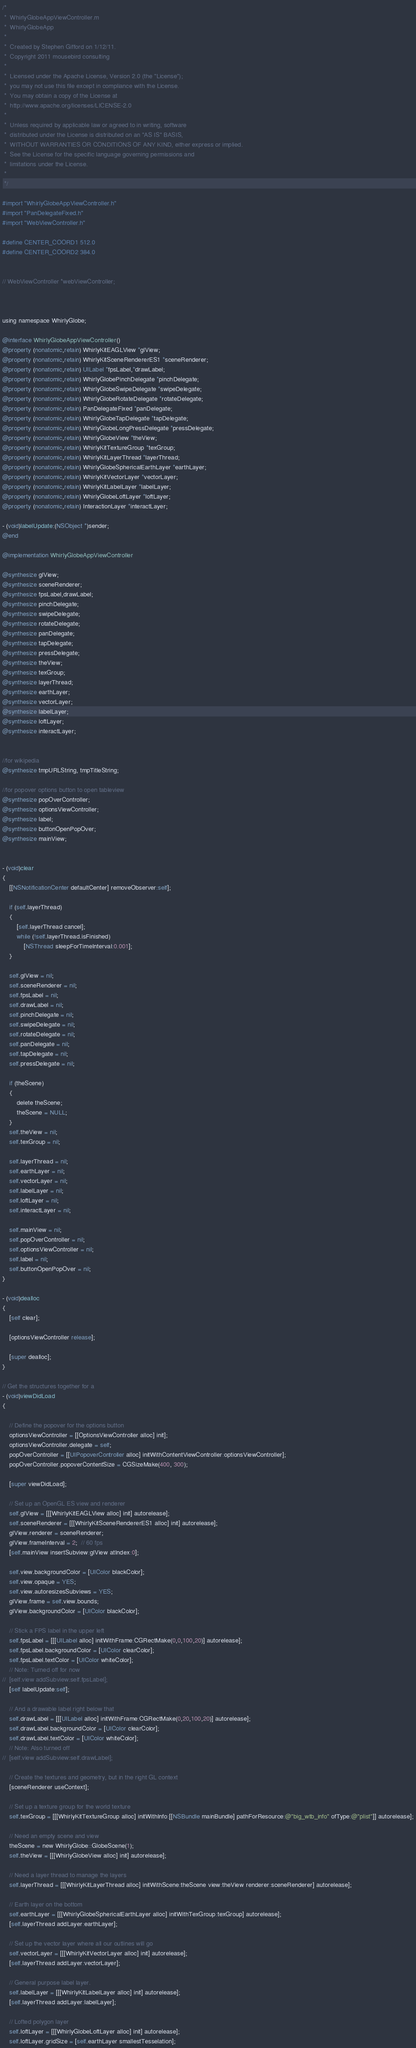Convert code to text. <code><loc_0><loc_0><loc_500><loc_500><_ObjectiveC_>/*
 *  WhirlyGlobeAppViewController.m
 *  WhirlyGlobeApp
 *
 *  Created by Stephen Gifford on 1/12/11.
 *  Copyright 2011 mousebird consulting
 *
 *  Licensed under the Apache License, Version 2.0 (the "License");
 *  you may not use this file except in compliance with the License.
 *  You may obtain a copy of the License at
 *  http://www.apache.org/licenses/LICENSE-2.0
 *
 *  Unless required by applicable law or agreed to in writing, software
 *  distributed under the License is distributed on an "AS IS" BASIS,
 *  WITHOUT WARRANTIES OR CONDITIONS OF ANY KIND, either express or implied.
 *  See the License for the specific language governing permissions and
 *  limitations under the License.
 *
 */

#import "WhirlyGlobeAppViewController.h"
#import "PanDelegateFixed.h"
#import "WebViewController.h"

#define CENTER_COORD1 512.0
#define CENTER_COORD2 384.0


// WebViewController *webViewController;



using namespace WhirlyGlobe;

@interface WhirlyGlobeAppViewController()
@property (nonatomic,retain) WhirlyKitEAGLView *glView;
@property (nonatomic,retain) WhirlyKitSceneRendererES1 *sceneRenderer;
@property (nonatomic,retain) UILabel *fpsLabel,*drawLabel;
@property (nonatomic,retain) WhirlyGlobePinchDelegate *pinchDelegate;
@property (nonatomic,retain) WhirlyGlobeSwipeDelegate *swipeDelegate;
@property (nonatomic,retain) WhirlyGlobeRotateDelegate *rotateDelegate;
@property (nonatomic,retain) PanDelegateFixed *panDelegate;
@property (nonatomic,retain) WhirlyGlobeTapDelegate *tapDelegate;
@property (nonatomic,retain) WhirlyGlobeLongPressDelegate *pressDelegate;
@property (nonatomic,retain) WhirlyGlobeView *theView;
@property (nonatomic,retain) WhirlyKitTextureGroup *texGroup;
@property (nonatomic,retain) WhirlyKitLayerThread *layerThread;
@property (nonatomic,retain) WhirlyGlobeSphericalEarthLayer *earthLayer;
@property (nonatomic,retain) WhirlyKitVectorLayer *vectorLayer;
@property (nonatomic,retain) WhirlyKitLabelLayer *labelLayer;
@property (nonatomic,retain) WhirlyGlobeLoftLayer *loftLayer;
@property (nonatomic,retain) InteractionLayer *interactLayer;

- (void)labelUpdate:(NSObject *)sender;
@end

@implementation WhirlyGlobeAppViewController

@synthesize glView;
@synthesize sceneRenderer;
@synthesize fpsLabel,drawLabel;
@synthesize pinchDelegate;
@synthesize swipeDelegate;
@synthesize rotateDelegate;
@synthesize panDelegate;
@synthesize tapDelegate;
@synthesize pressDelegate;
@synthesize theView;
@synthesize texGroup;
@synthesize layerThread;
@synthesize earthLayer;
@synthesize vectorLayer;
@synthesize labelLayer;
@synthesize loftLayer;
@synthesize interactLayer;


//for wikipedia
@synthesize tmpURLString, tmpTitleString;

//for popover options button to open tableview
@synthesize popOverController;
@synthesize optionsViewController;
@synthesize label;
@synthesize buttonOpenPopOver;
@synthesize mainView;


- (void)clear
{
	[[NSNotificationCenter defaultCenter] removeObserver:self];

    if (self.layerThread)
    {
        [self.layerThread cancel];
        while (!self.layerThread.isFinished)
            [NSThread sleepForTimeInterval:0.001];
    }

    self.glView = nil;
    self.sceneRenderer = nil;
    self.fpsLabel = nil;
    self.drawLabel = nil;
    self.pinchDelegate = nil;
    self.swipeDelegate = nil;
    self.rotateDelegate = nil;
    self.panDelegate = nil;
    self.tapDelegate = nil;
    self.pressDelegate = nil;
    
    if (theScene)
    {
        delete theScene;
        theScene = NULL;
    }
    self.theView = nil;
    self.texGroup = nil;
    
    self.layerThread = nil;
    self.earthLayer = nil;
    self.vectorLayer = nil;
    self.labelLayer = nil;
    self.loftLayer = nil;
    self.interactLayer = nil;
    
    self.mainView = nil;
    self.popOverController = nil;
    self.optionsViewController = nil;
    self.label = nil;
    self.buttonOpenPopOver = nil;
}

- (void)dealloc 
{
    [self clear];
    
    [optionsViewController release];
    
    [super dealloc];
}

// Get the structures together for a 
- (void)viewDidLoad 
{
    
    // Define the popover for the options button
    optionsViewController = [[OptionsViewController alloc] init];
    optionsViewController.delegate = self;
    popOverController = [[UIPopoverController alloc] initWithContentViewController:optionsViewController];
    popOverController.popoverContentSize = CGSizeMake(400, 300);
    
    [super viewDidLoad];
	
	// Set up an OpenGL ES view and renderer
	self.glView = [[[WhirlyKitEAGLView alloc] init] autorelease];
	self.sceneRenderer = [[[WhirlyKitSceneRendererES1 alloc] init] autorelease];
	glView.renderer = sceneRenderer;
	glView.frameInterval = 2;  // 60 fps
    [self.mainView insertSubview:glView atIndex:0];

    self.view.backgroundColor = [UIColor blackColor];
    self.view.opaque = YES;
	self.view.autoresizesSubviews = YES;
	glView.frame = self.view.bounds;
    glView.backgroundColor = [UIColor blackColor];
	
	// Stick a FPS label in the upper left
	self.fpsLabel = [[[UILabel alloc] initWithFrame:CGRectMake(0,0,100,20)] autorelease];
	self.fpsLabel.backgroundColor = [UIColor clearColor];
	self.fpsLabel.textColor = [UIColor whiteColor];
    // Note: Turned off for now
//	[self.view addSubview:self.fpsLabel];
	[self labelUpdate:self];
	
	// And a drawable label right below that
	self.drawLabel = [[[UILabel alloc] initWithFrame:CGRectMake(0,20,100,20)] autorelease];
	self.drawLabel.backgroundColor = [UIColor clearColor];
	self.drawLabel.textColor = [UIColor whiteColor];
    // Note: Also turned off
//	[self.view addSubview:self.drawLabel];

	// Create the textures and geometry, but in the right GL context
	[sceneRenderer useContext];
	
	// Set up a texture group for the world texture
	self.texGroup = [[[WhirlyKitTextureGroup alloc] initWithInfo:[[NSBundle mainBundle] pathForResource:@"big_wtb_info" ofType:@"plist"]] autorelease];

	// Need an empty scene and view
	theScene = new WhirlyGlobe::GlobeScene(1);
	self.theView = [[[WhirlyGlobeView alloc] init] autorelease];
	
	// Need a layer thread to manage the layers
	self.layerThread = [[[WhirlyKitLayerThread alloc] initWithScene:theScene view:theView renderer:sceneRenderer] autorelease];
	
	// Earth layer on the bottom
	self.earthLayer = [[[WhirlyGlobeSphericalEarthLayer alloc] initWithTexGroup:texGroup] autorelease];
	[self.layerThread addLayer:earthLayer];

	// Set up the vector layer where all our outlines will go
	self.vectorLayer = [[[WhirlyKitVectorLayer alloc] init] autorelease];
	[self.layerThread addLayer:vectorLayer];

	// General purpose label layer.
	self.labelLayer = [[[WhirlyKitLabelLayer alloc] init] autorelease];
	[self.layerThread addLayer:labelLayer];
    
    // Lofted polygon layer
    self.loftLayer = [[[WhirlyGlobeLoftLayer alloc] init] autorelease];
    self.loftLayer.gridSize = [self.earthLayer smallestTesselation];</code> 